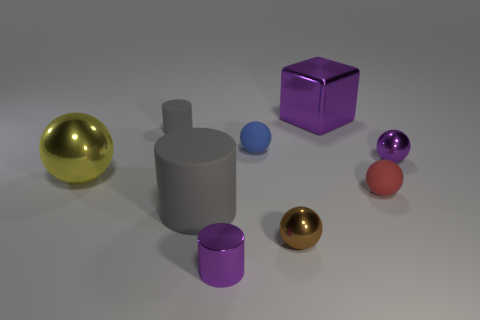Imagine these objects are part of a puzzle, what could be the objective? If these objects were part of a puzzle, the objective might involve sorting or arranging them by some criteria - such as size, color, material, or shape - or perhaps positioning them to achieve a specific configuration or balance. 